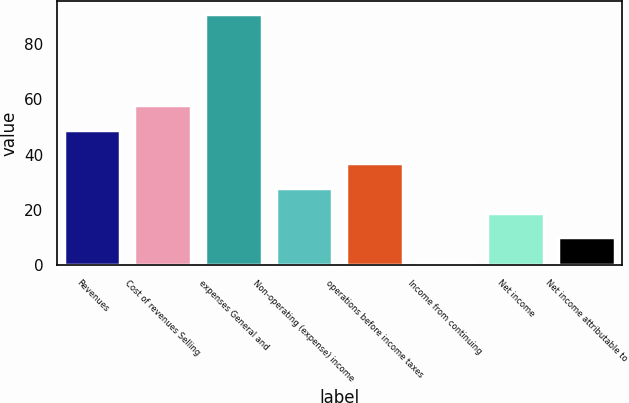Convert chart to OTSL. <chart><loc_0><loc_0><loc_500><loc_500><bar_chart><fcel>Revenues<fcel>Cost of revenues Selling<fcel>expenses General and<fcel>Non-operating (expense) income<fcel>operations before income taxes<fcel>Income from continuing<fcel>Net income<fcel>Net income attributable to<nl><fcel>49<fcel>58<fcel>91<fcel>28<fcel>37<fcel>1<fcel>19<fcel>10<nl></chart> 